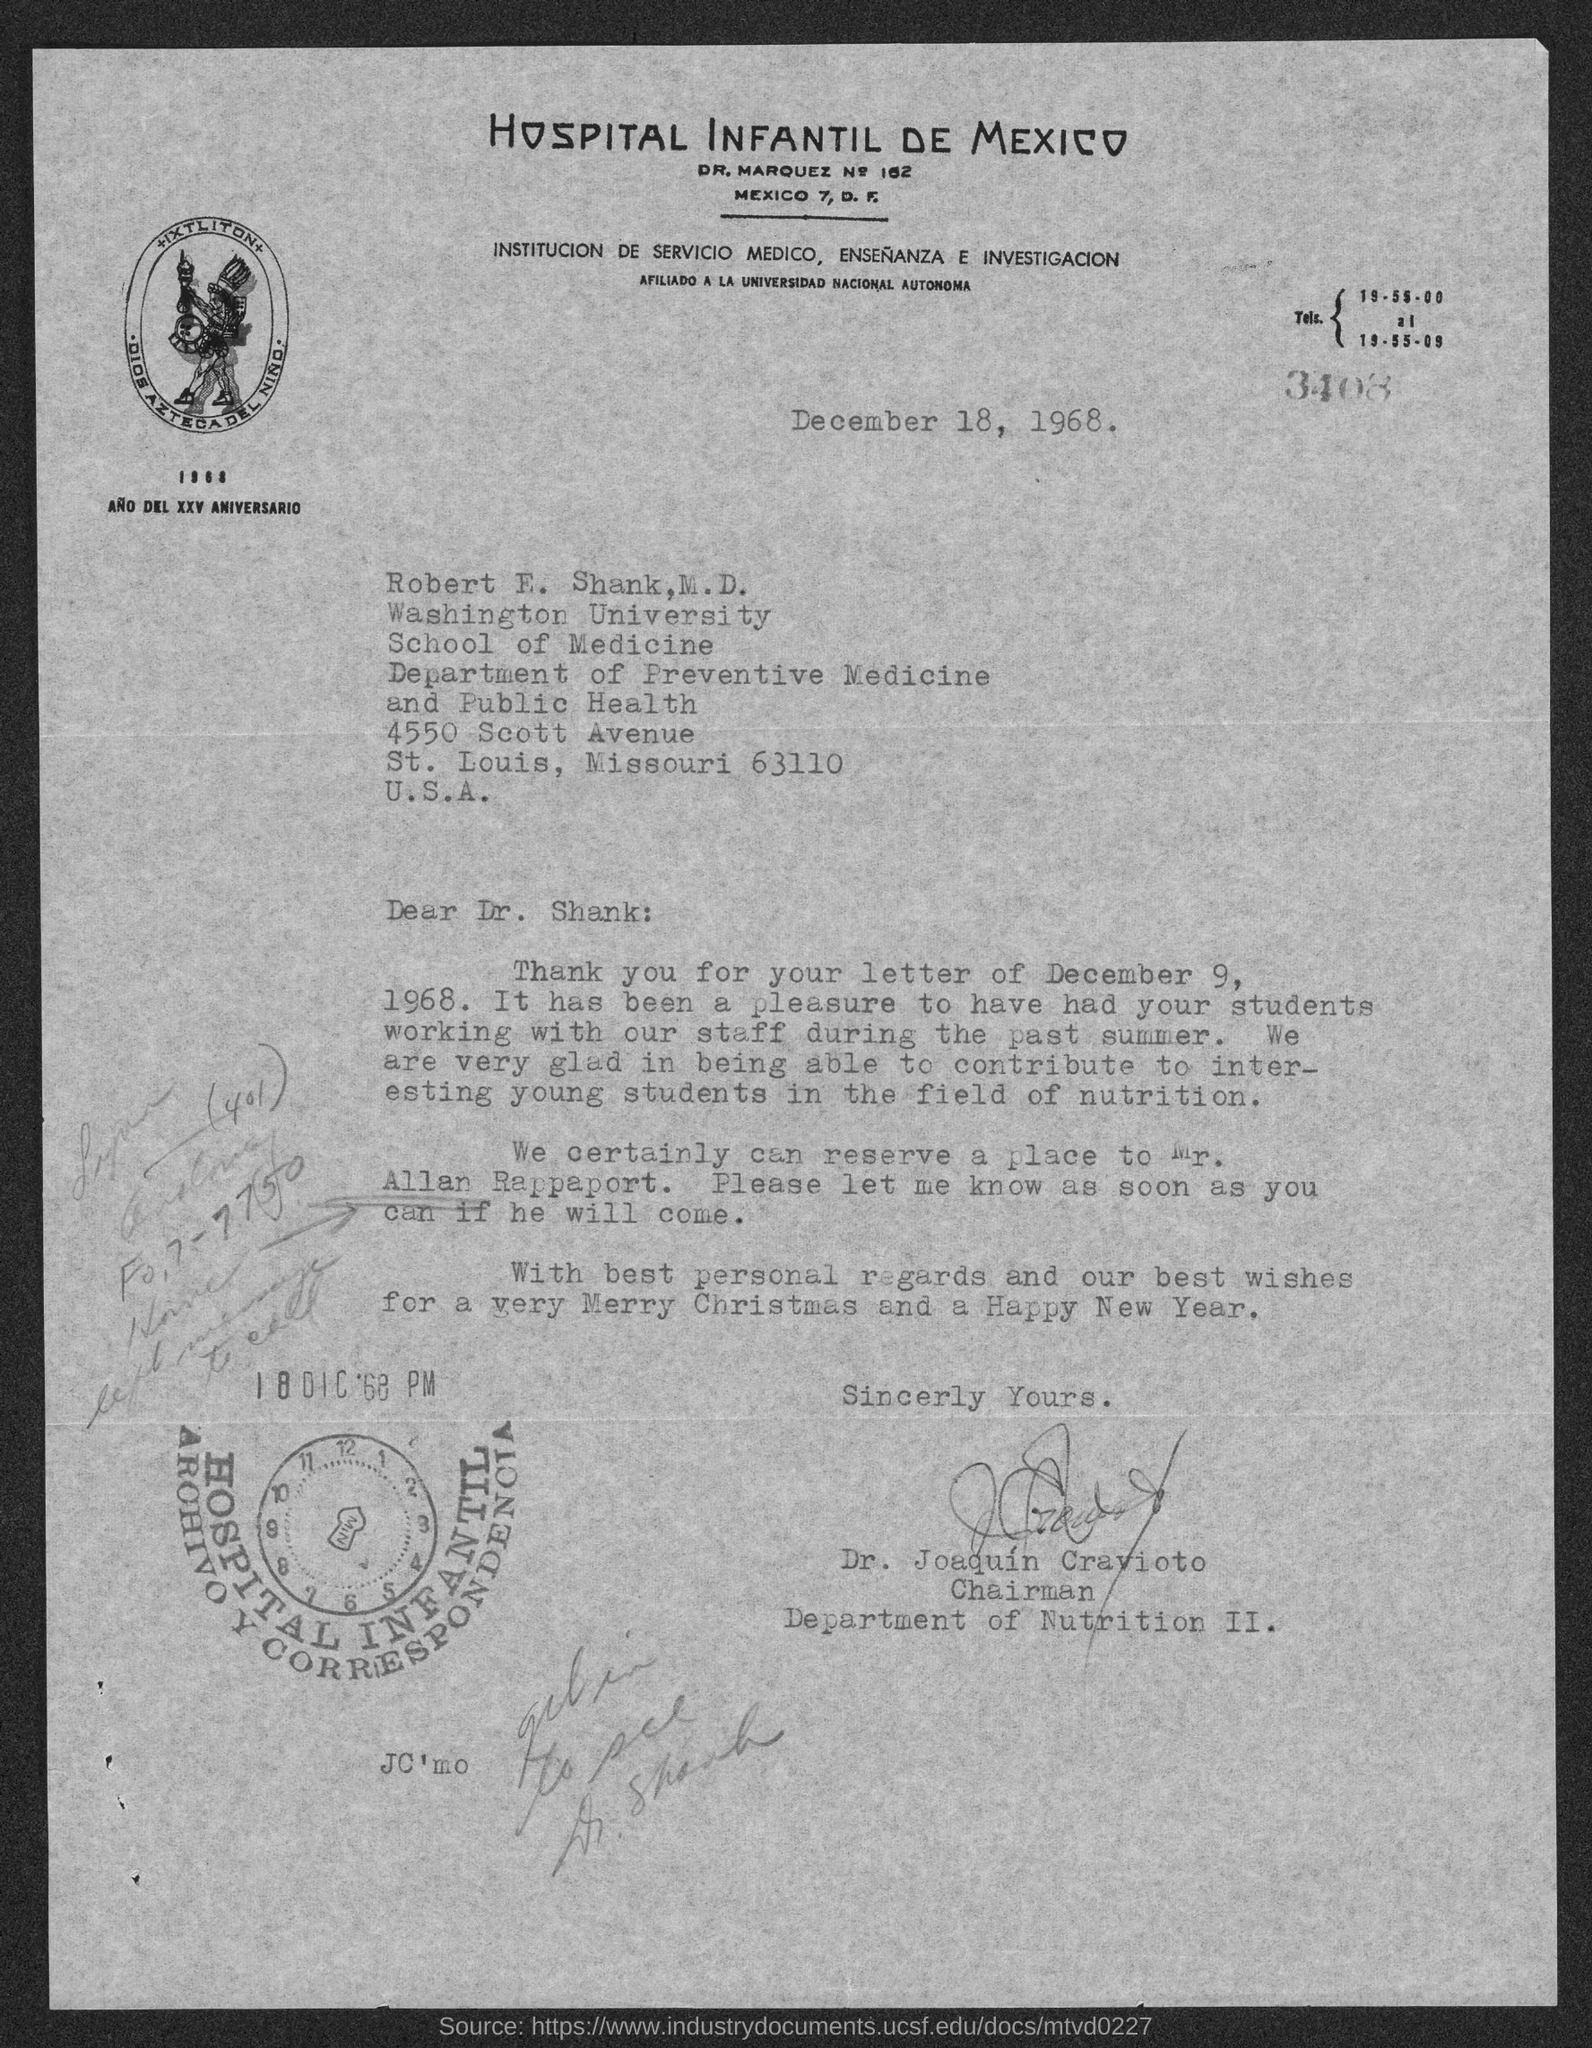What is written in the top of the document ?
Give a very brief answer. Hospital Infantil De Mexico. What is the date mentioned in the top of the document ?
Your answer should be very brief. December 18, 1968. 